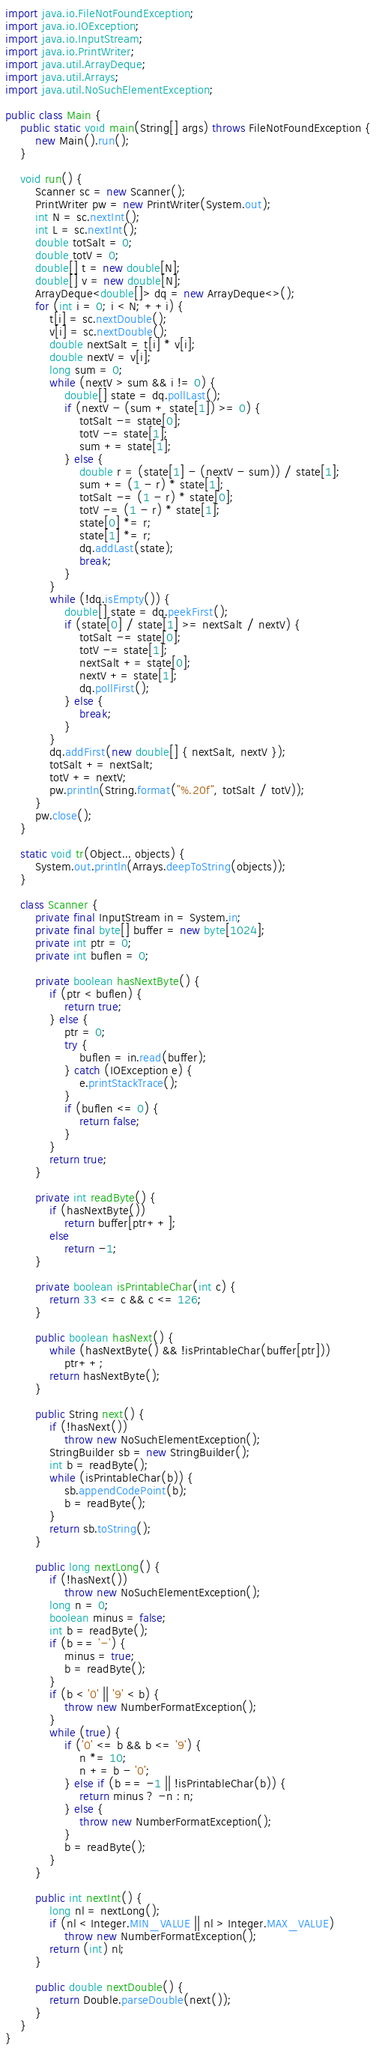<code> <loc_0><loc_0><loc_500><loc_500><_Java_>import java.io.FileNotFoundException;
import java.io.IOException;
import java.io.InputStream;
import java.io.PrintWriter;
import java.util.ArrayDeque;
import java.util.Arrays;
import java.util.NoSuchElementException;

public class Main {
	public static void main(String[] args) throws FileNotFoundException {
		new Main().run();
	}

	void run() {
		Scanner sc = new Scanner();
		PrintWriter pw = new PrintWriter(System.out);
		int N = sc.nextInt();
		int L = sc.nextInt();
		double totSalt = 0;
		double totV = 0;
		double[] t = new double[N];
		double[] v = new double[N];
		ArrayDeque<double[]> dq = new ArrayDeque<>();
		for (int i = 0; i < N; ++i) {
			t[i] = sc.nextDouble();
			v[i] = sc.nextDouble();
			double nextSalt = t[i] * v[i];
			double nextV = v[i];
			long sum = 0;
			while (nextV > sum && i != 0) {
				double[] state = dq.pollLast();
				if (nextV - (sum + state[1]) >= 0) {
					totSalt -= state[0];
					totV -= state[1];
					sum += state[1];
				} else {
					double r = (state[1] - (nextV - sum)) / state[1];
					sum += (1 - r) * state[1];
					totSalt -= (1 - r) * state[0];
					totV -= (1 - r) * state[1];
					state[0] *= r;
					state[1] *= r;
					dq.addLast(state);
					break;
				}
			}
			while (!dq.isEmpty()) {
				double[] state = dq.peekFirst();
				if (state[0] / state[1] >= nextSalt / nextV) {
					totSalt -= state[0];
					totV -= state[1];
					nextSalt += state[0];
					nextV += state[1];
					dq.pollFirst();
				} else {
					break;
				}
			}
			dq.addFirst(new double[] { nextSalt, nextV });
			totSalt += nextSalt;
			totV += nextV;
			pw.println(String.format("%.20f", totSalt / totV));
		}
		pw.close();
	}

	static void tr(Object... objects) {
		System.out.println(Arrays.deepToString(objects));
	}

	class Scanner {
		private final InputStream in = System.in;
		private final byte[] buffer = new byte[1024];
		private int ptr = 0;
		private int buflen = 0;

		private boolean hasNextByte() {
			if (ptr < buflen) {
				return true;
			} else {
				ptr = 0;
				try {
					buflen = in.read(buffer);
				} catch (IOException e) {
					e.printStackTrace();
				}
				if (buflen <= 0) {
					return false;
				}
			}
			return true;
		}

		private int readByte() {
			if (hasNextByte())
				return buffer[ptr++];
			else
				return -1;
		}

		private boolean isPrintableChar(int c) {
			return 33 <= c && c <= 126;
		}

		public boolean hasNext() {
			while (hasNextByte() && !isPrintableChar(buffer[ptr]))
				ptr++;
			return hasNextByte();
		}

		public String next() {
			if (!hasNext())
				throw new NoSuchElementException();
			StringBuilder sb = new StringBuilder();
			int b = readByte();
			while (isPrintableChar(b)) {
				sb.appendCodePoint(b);
				b = readByte();
			}
			return sb.toString();
		}

		public long nextLong() {
			if (!hasNext())
				throw new NoSuchElementException();
			long n = 0;
			boolean minus = false;
			int b = readByte();
			if (b == '-') {
				minus = true;
				b = readByte();
			}
			if (b < '0' || '9' < b) {
				throw new NumberFormatException();
			}
			while (true) {
				if ('0' <= b && b <= '9') {
					n *= 10;
					n += b - '0';
				} else if (b == -1 || !isPrintableChar(b)) {
					return minus ? -n : n;
				} else {
					throw new NumberFormatException();
				}
				b = readByte();
			}
		}

		public int nextInt() {
			long nl = nextLong();
			if (nl < Integer.MIN_VALUE || nl > Integer.MAX_VALUE)
				throw new NumberFormatException();
			return (int) nl;
		}

		public double nextDouble() {
			return Double.parseDouble(next());
		}
	}
}
</code> 